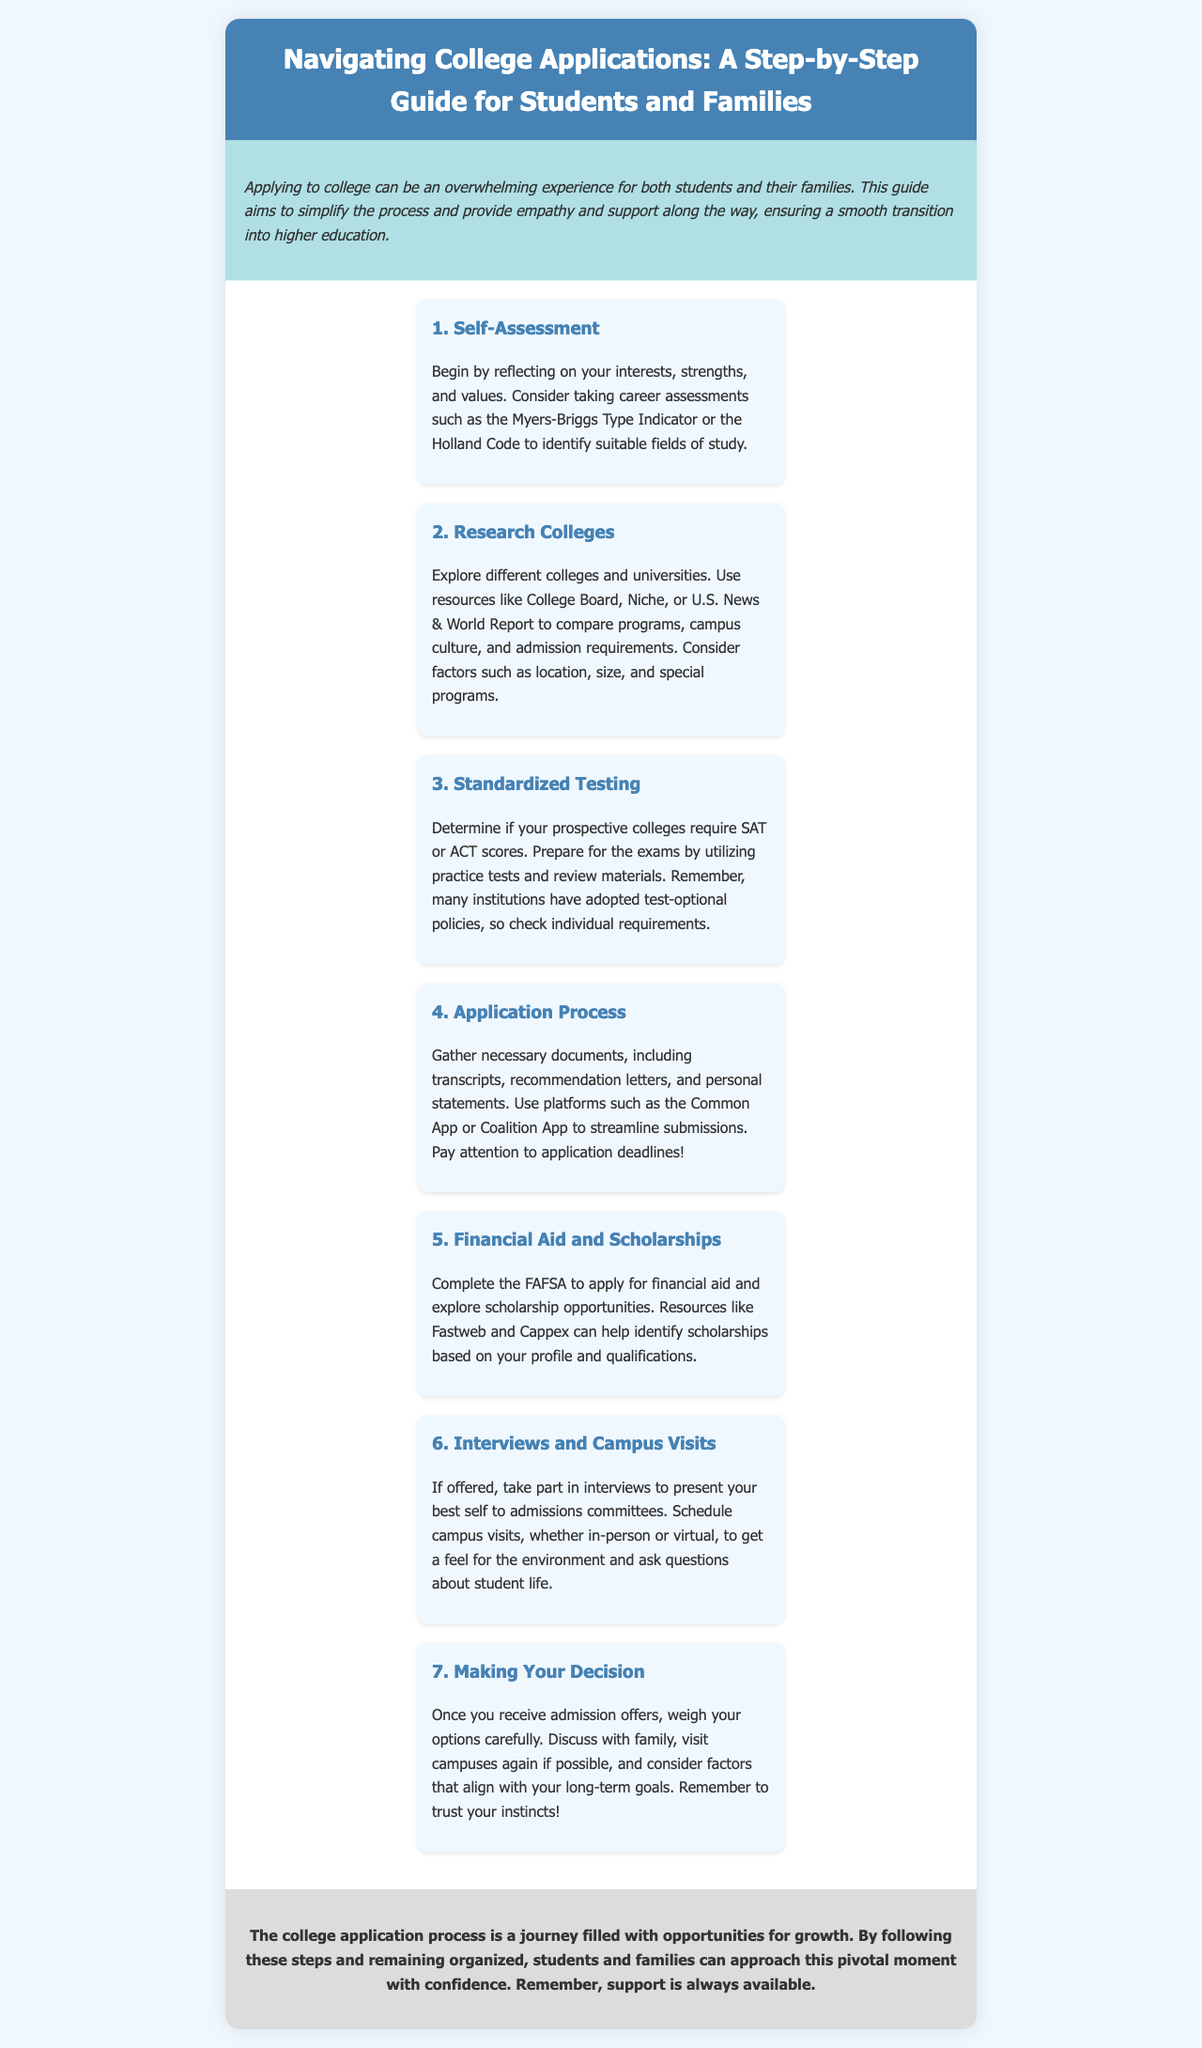What is the title of the brochure? The title is clearly stated in the header section of the document.
Answer: Navigating College Applications: A Step-by-Step Guide for Students and Families What is the color of the header? The header's background color is indicated in the style section of the document.
Answer: #4682b4 How many steps are outlined in the guide? The number of steps is explicitly listed in the content of the brochure.
Answer: 7 What is the first step in the application process? The first step is mentioned at the beginning of the steps section.
Answer: Self-Assessment What should students consider in the research phase? The details in the "Research Colleges" section specify different factors to explore.
Answer: Location, size, and special programs What document must be completed for financial aid? The requirements for financial aid are provided in the corresponding step.
Answer: FAFSA What is suggested for preparing for standardized tests? The guide advises certain methods for exam preparation.
Answer: Practice tests and review materials What does the conclusion emphasize? The concluding section highlights an important takeaway for students and families.
Answer: Support is always available Why might a student choose to visit campuses again? This is discussed in the "Making Your Decision" step, mentioning advantages of revisiting.
Answer: To weigh options carefully 